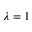<formula> <loc_0><loc_0><loc_500><loc_500>\lambda = 1</formula> 